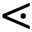Convert formula to latex. <formula><loc_0><loc_0><loc_500><loc_500>\leq s s d o t</formula> 